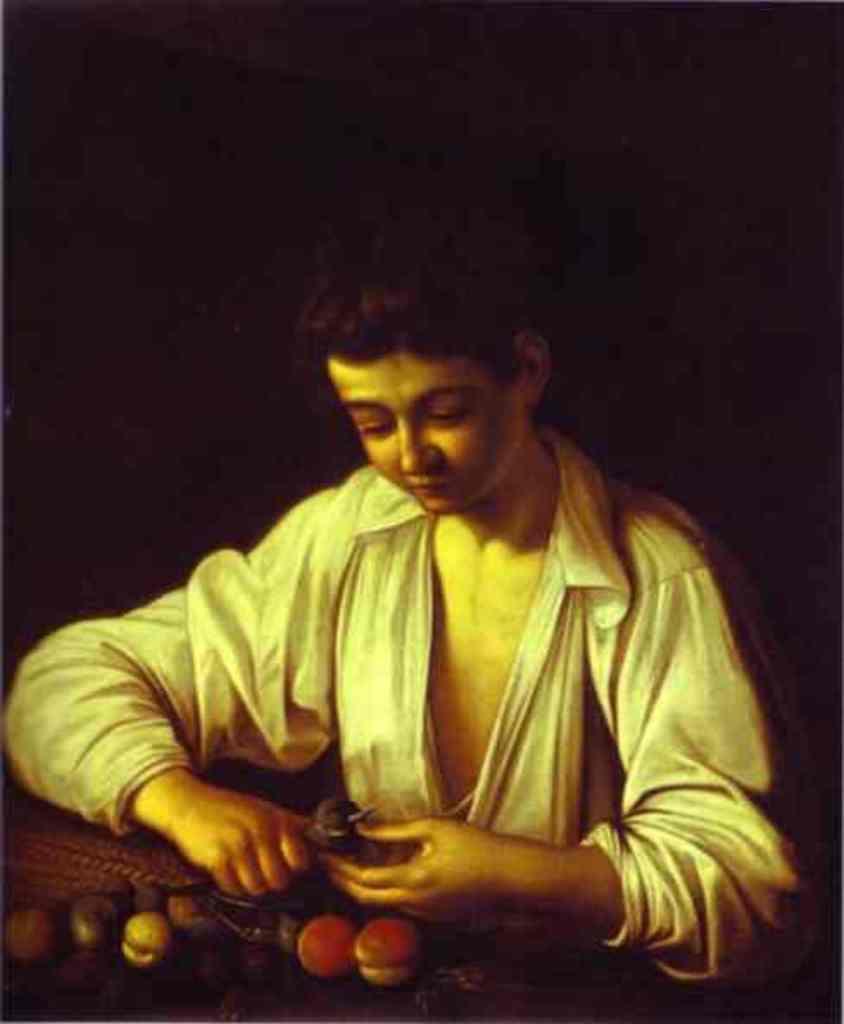How would you summarize this image in a sentence or two? In this picture we can see a painting and we can find dark background. 